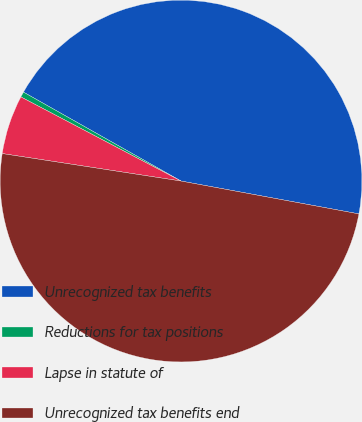<chart> <loc_0><loc_0><loc_500><loc_500><pie_chart><fcel>Unrecognized tax benefits<fcel>Reductions for tax positions<fcel>Lapse in statute of<fcel>Unrecognized tax benefits end<nl><fcel>44.73%<fcel>0.48%<fcel>5.27%<fcel>49.52%<nl></chart> 